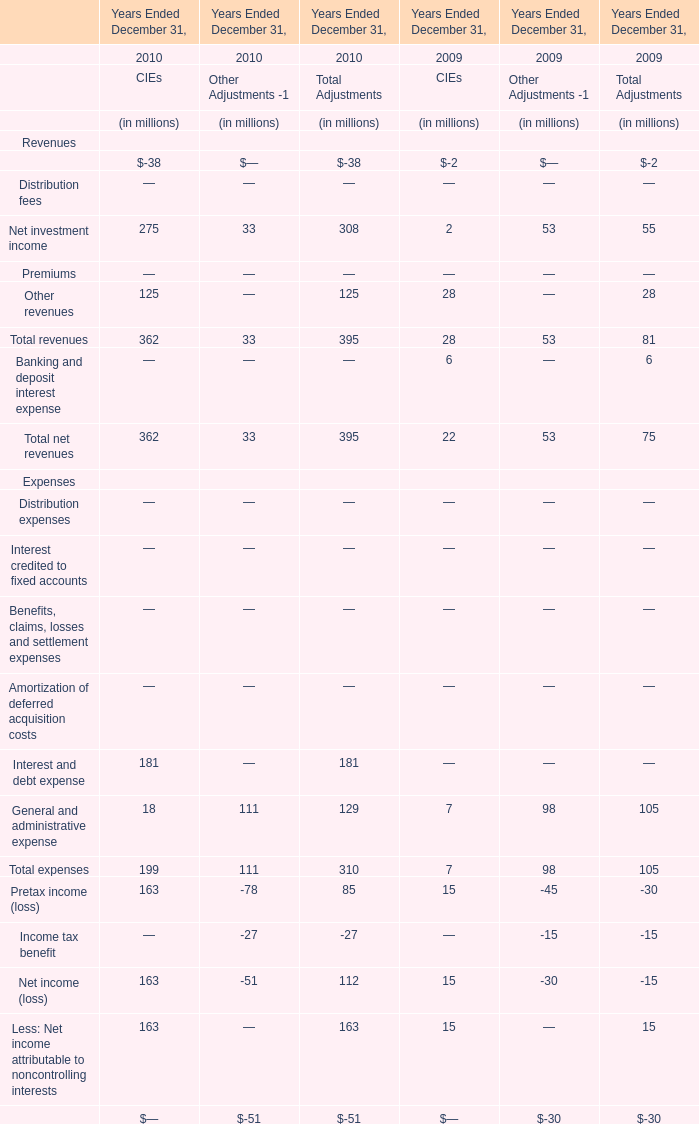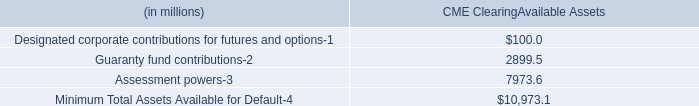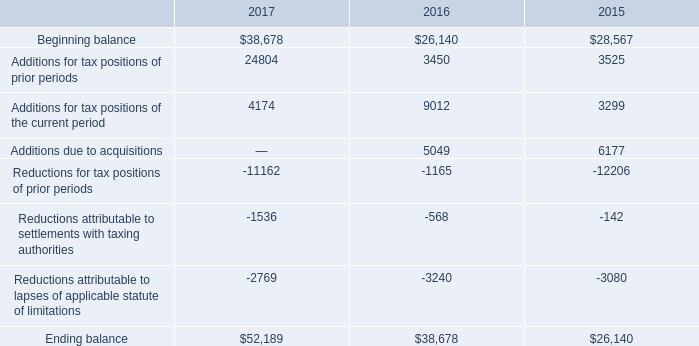what's the total amount of Ending balance of 2016, Guaranty fund contributions of CME ClearingAvailable Assets, and Reductions attributable to lapses of applicable statute of limitations of 2015 ? 
Computations: ((38678.0 + 2899.5) + 3080.0)
Answer: 44657.5. 